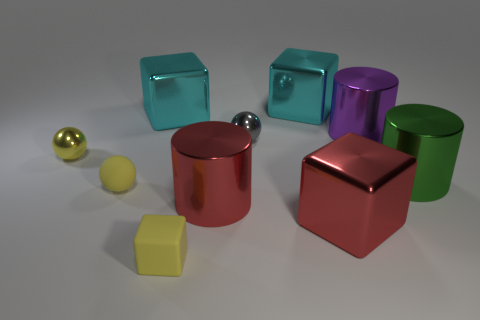How would you interpret the arrangement of the objects in this image? The arrangement of the objects may be intentionally designed to showcase diversity in color, shape, and size, which could imply a theme of variety or contrast, inviting viewers to compare and contrast the different elements. Additionally, the lighting and shadows contribute to the presentation, hinting at a carefully orchestrated composition. 